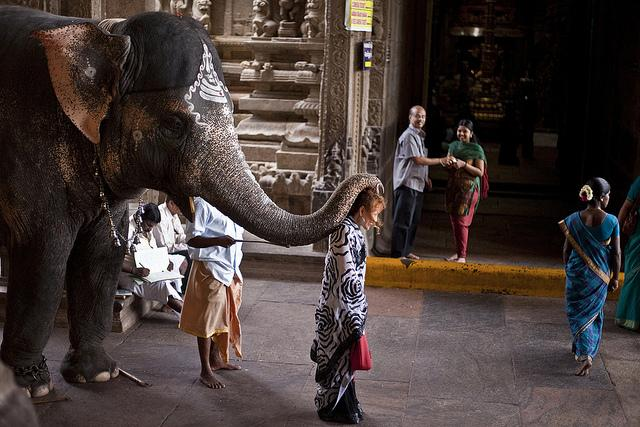What is the type of garment that the woman in blue is wearing? Please explain your reasoning. sari. The woman has a sari on. 